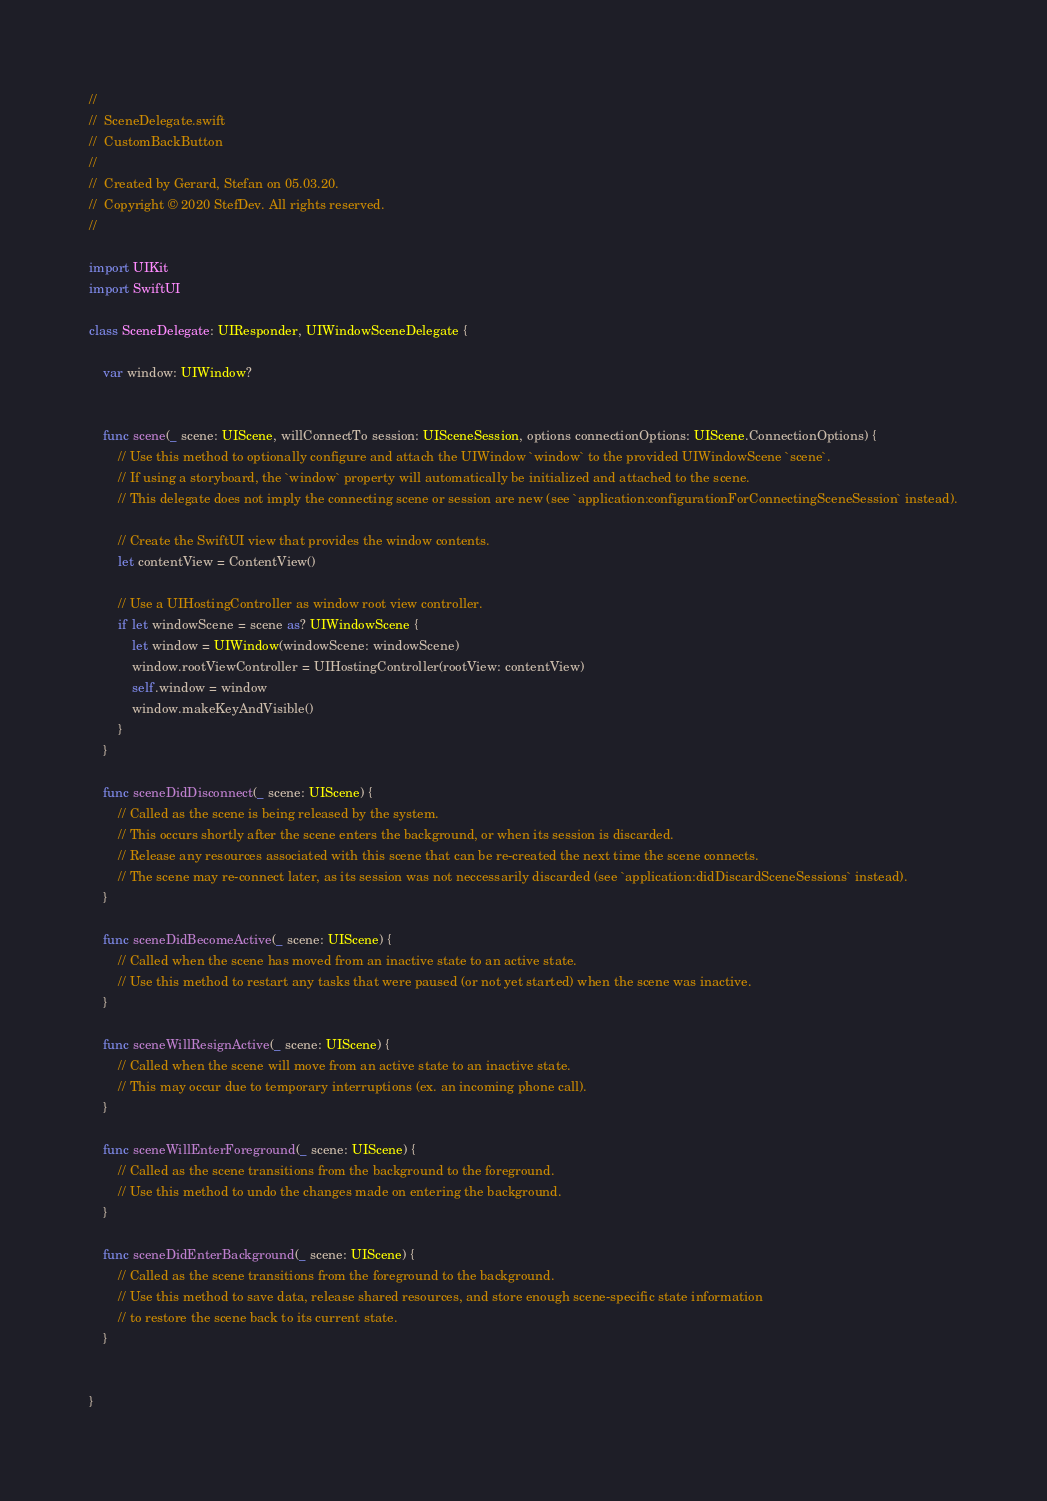Convert code to text. <code><loc_0><loc_0><loc_500><loc_500><_Swift_>//
//  SceneDelegate.swift
//  CustomBackButton
//
//  Created by Gerard, Stefan on 05.03.20.
//  Copyright © 2020 StefDev. All rights reserved.
//

import UIKit
import SwiftUI

class SceneDelegate: UIResponder, UIWindowSceneDelegate {

    var window: UIWindow?


    func scene(_ scene: UIScene, willConnectTo session: UISceneSession, options connectionOptions: UIScene.ConnectionOptions) {
        // Use this method to optionally configure and attach the UIWindow `window` to the provided UIWindowScene `scene`.
        // If using a storyboard, the `window` property will automatically be initialized and attached to the scene.
        // This delegate does not imply the connecting scene or session are new (see `application:configurationForConnectingSceneSession` instead).

        // Create the SwiftUI view that provides the window contents.
        let contentView = ContentView()

        // Use a UIHostingController as window root view controller.
        if let windowScene = scene as? UIWindowScene {
            let window = UIWindow(windowScene: windowScene)
            window.rootViewController = UIHostingController(rootView: contentView)
            self.window = window
            window.makeKeyAndVisible()
        }
    }

    func sceneDidDisconnect(_ scene: UIScene) {
        // Called as the scene is being released by the system.
        // This occurs shortly after the scene enters the background, or when its session is discarded.
        // Release any resources associated with this scene that can be re-created the next time the scene connects.
        // The scene may re-connect later, as its session was not neccessarily discarded (see `application:didDiscardSceneSessions` instead).
    }

    func sceneDidBecomeActive(_ scene: UIScene) {
        // Called when the scene has moved from an inactive state to an active state.
        // Use this method to restart any tasks that were paused (or not yet started) when the scene was inactive.
    }

    func sceneWillResignActive(_ scene: UIScene) {
        // Called when the scene will move from an active state to an inactive state.
        // This may occur due to temporary interruptions (ex. an incoming phone call).
    }

    func sceneWillEnterForeground(_ scene: UIScene) {
        // Called as the scene transitions from the background to the foreground.
        // Use this method to undo the changes made on entering the background.
    }

    func sceneDidEnterBackground(_ scene: UIScene) {
        // Called as the scene transitions from the foreground to the background.
        // Use this method to save data, release shared resources, and store enough scene-specific state information
        // to restore the scene back to its current state.
    }


}

</code> 